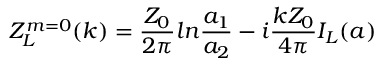Convert formula to latex. <formula><loc_0><loc_0><loc_500><loc_500>Z _ { L } ^ { m = 0 } ( k ) = \frac { Z _ { 0 } } { 2 \pi } \ln \frac { a _ { 1 } } { a _ { 2 } } - i \frac { k Z _ { 0 } } { 4 \pi } I _ { L } ( a )</formula> 